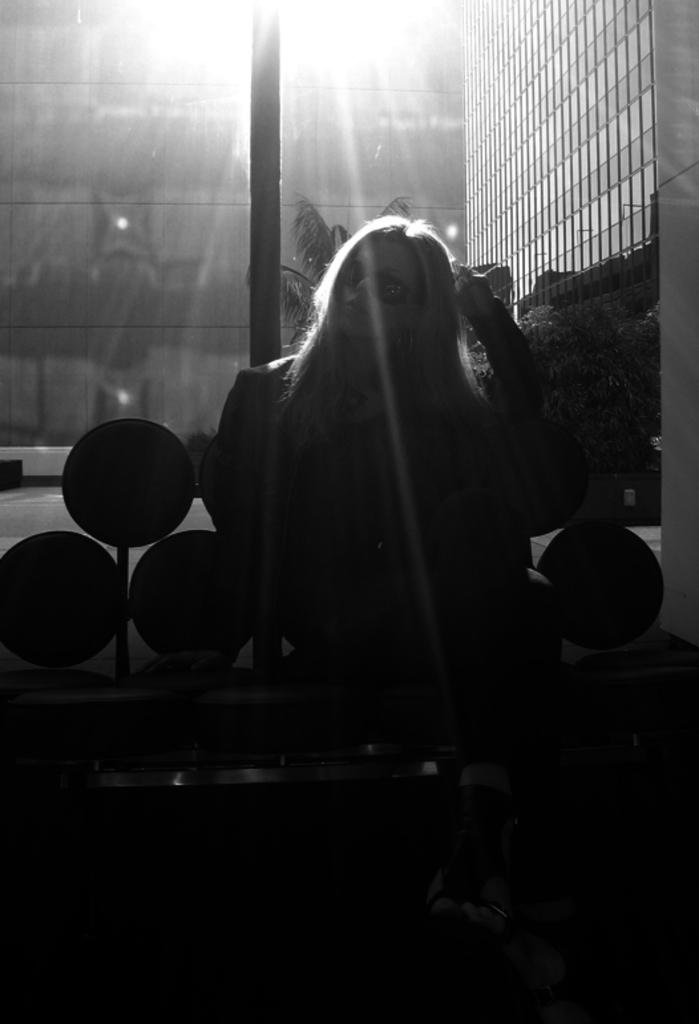What is the woman in the image doing? The woman is sitting on a bench in the image. What can be seen in the background of the image? There are buildings, plants, and lights in the background of the image. What type of rake is the baby using to clean the island in the image? There is no rake, baby, or island present in the image. 